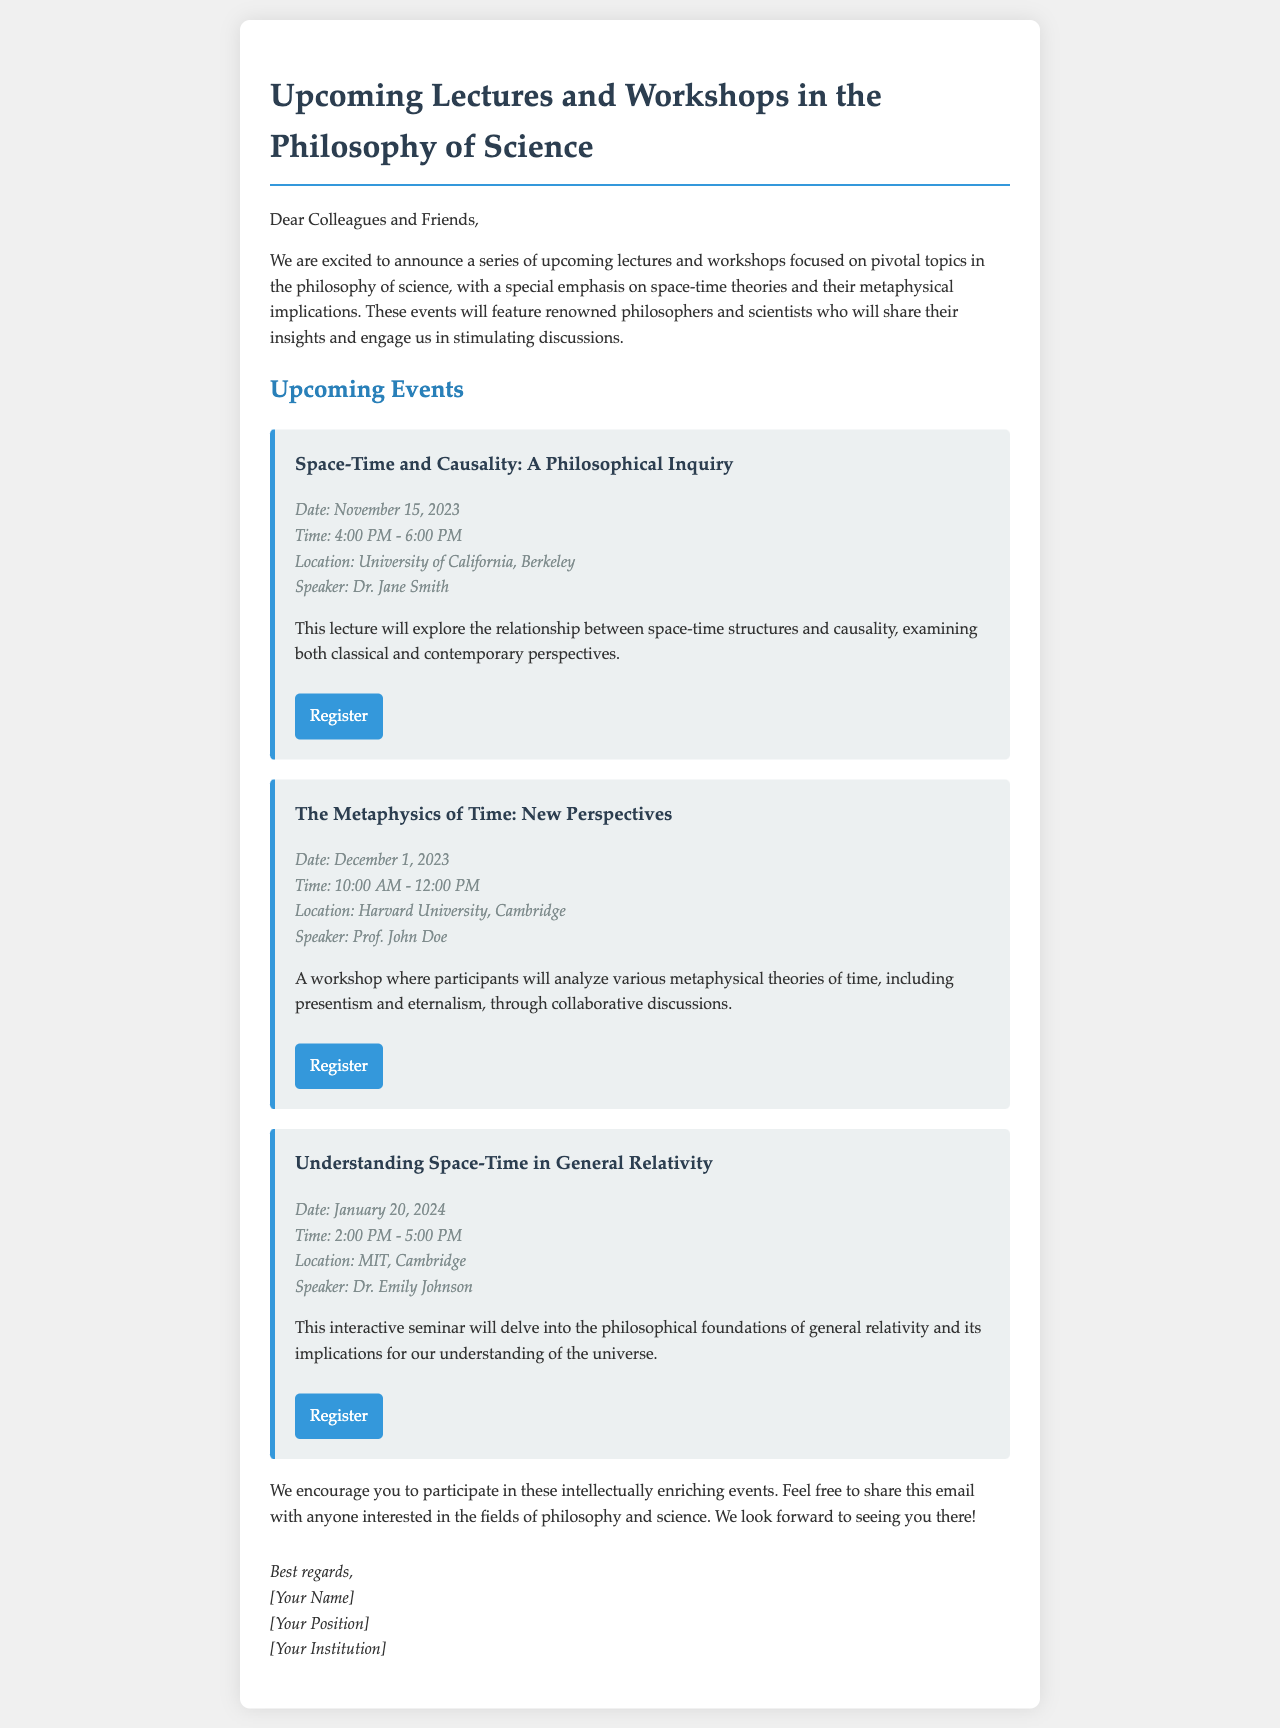What is the title of the first lecture? The title of the first lecture is found in the event section where the first event is described.
Answer: Space-Time and Causality: A Philosophical Inquiry Who is the speaker for the workshop on December 1, 2023? The speaker's name is provided in the event details for the second event.
Answer: Prof. John Doe When is the seminar on general relativity scheduled? The date for the seminar is noted within the event details of the third event listed.
Answer: January 20, 2024 What is the location of the first event? The location can be found in the event details for the first lecture.
Answer: University of California, Berkeley What type of event is scheduled for December 1, 2023? The type of event is indicated in the description of the second event, which specifies the nature of the meeting.
Answer: Workshop How long is the Space-Time and Causality lecture? The duration of the first event is specified in the event details section, indicating the time range.
Answer: 2 hours What is the focus of the workshops mentioned? The document emphasizes the overarching themes of the newsletter, which details the content of the events.
Answer: Space-time theories and their metaphysical implications Who is sending out this newsletter? The sender's details are typically located at the end of such newsletters, specifically in the signature part.
Answer: [Your Name] 